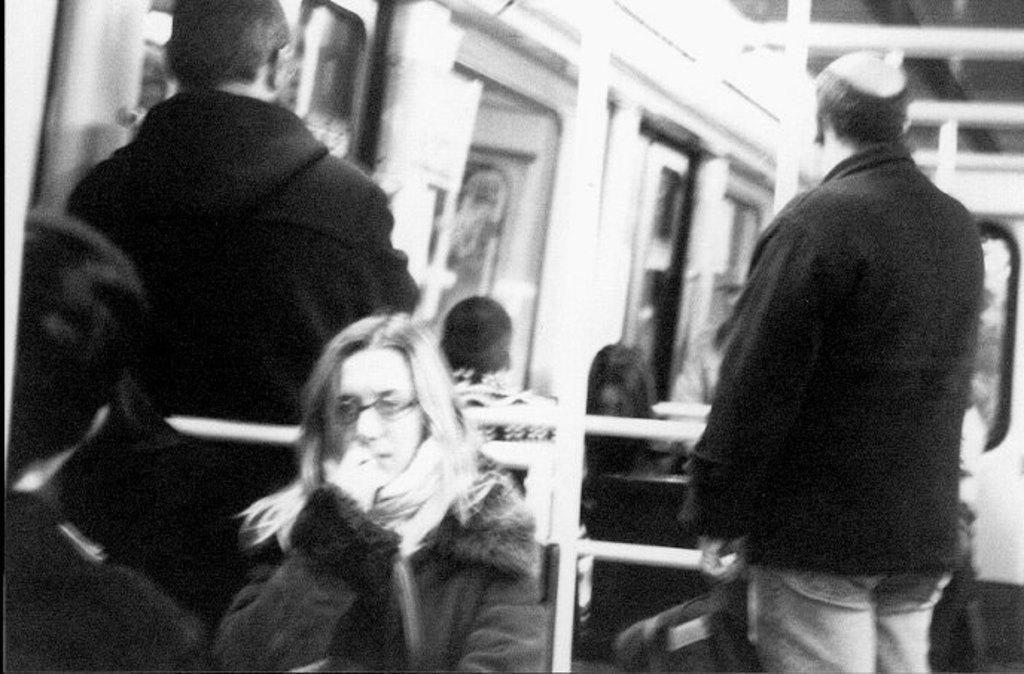How would you summarize this image in a sentence or two? This is a black and white image. This picture is an inside view of a vehicle. In this picture we can see some persons are sitting on the seats. On the left and right side of the image we can see two persons are standing. In the background of the image we can see the rods, windows, door, roof. 